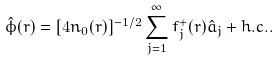<formula> <loc_0><loc_0><loc_500><loc_500>\hat { \phi } ( { r } ) = [ 4 n _ { 0 } ( { r } ) ] ^ { - 1 / 2 } \sum _ { j = 1 } ^ { \infty } f _ { j } ^ { + } ( { r } ) \hat { a } _ { j } + h . c . .</formula> 